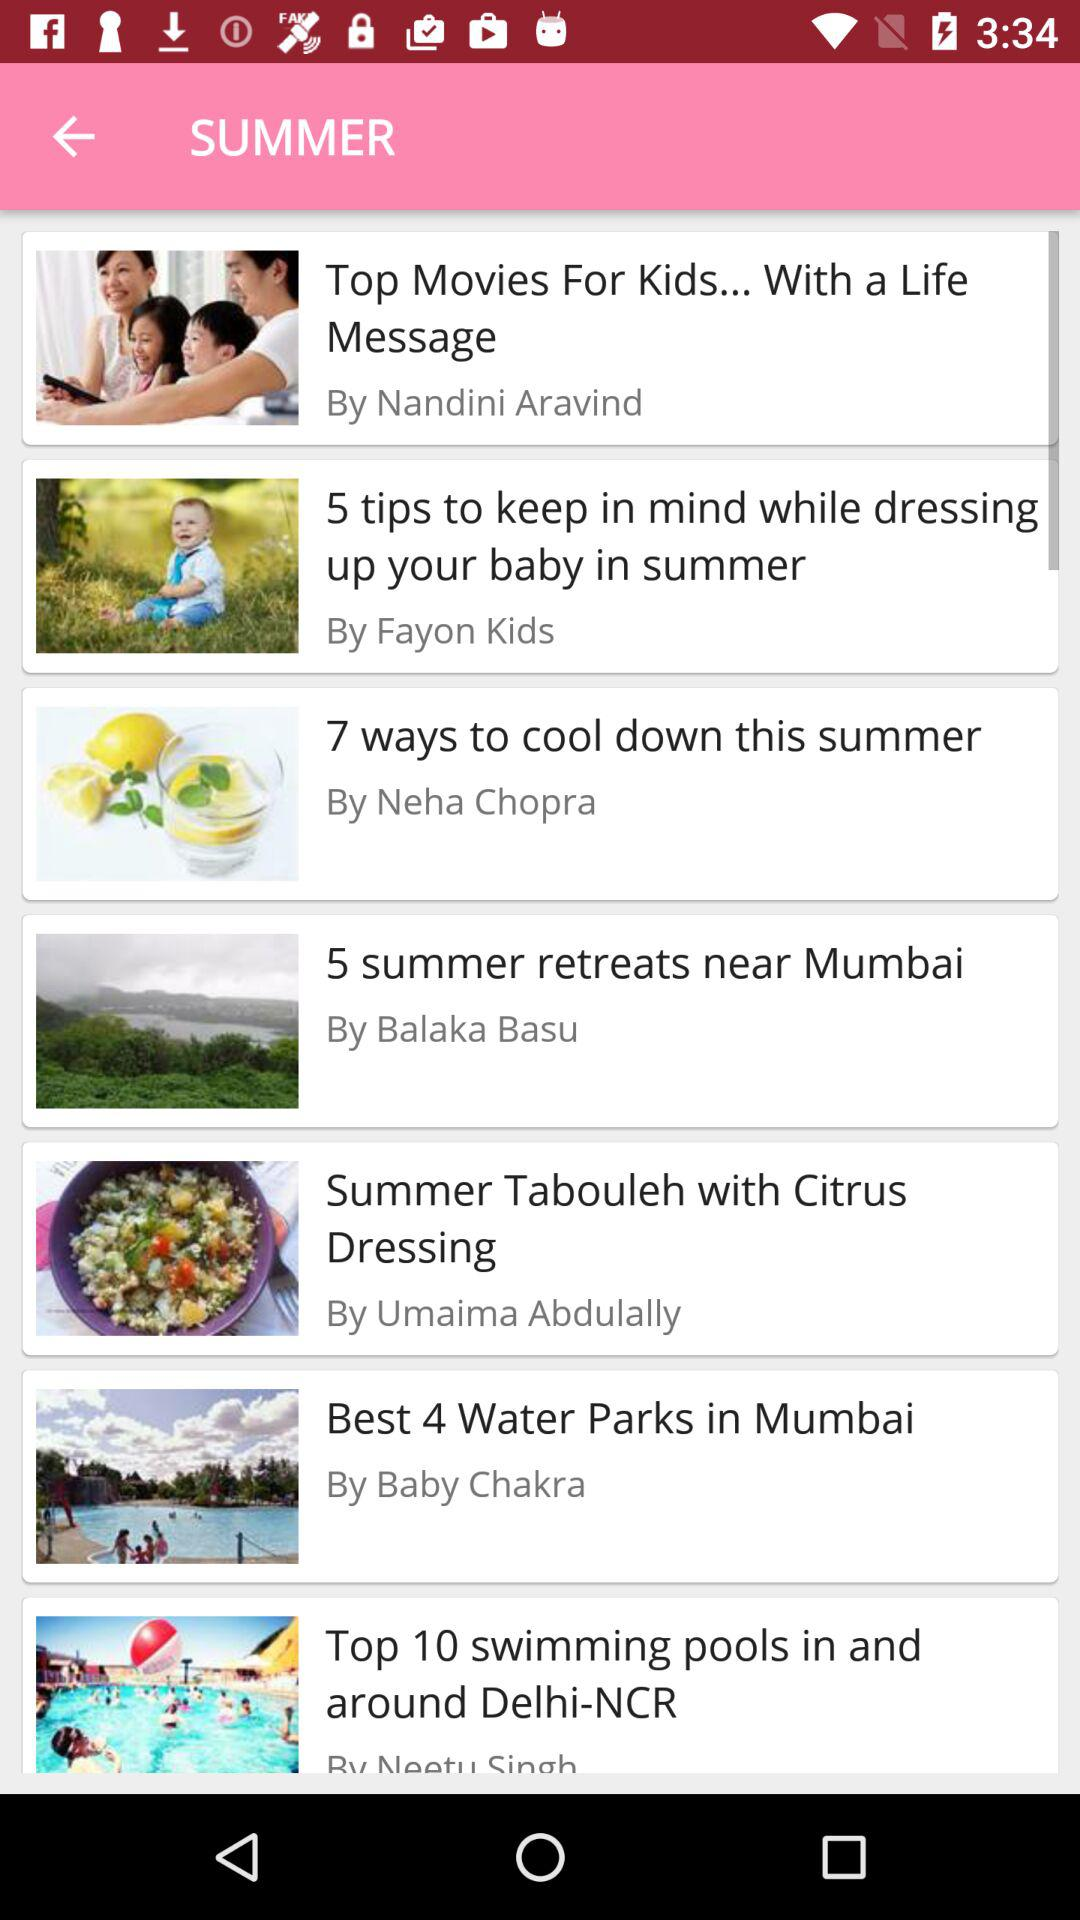What are ways suggested by balaka basu?
When the provided information is insufficient, respond with <no answer>. <no answer> 